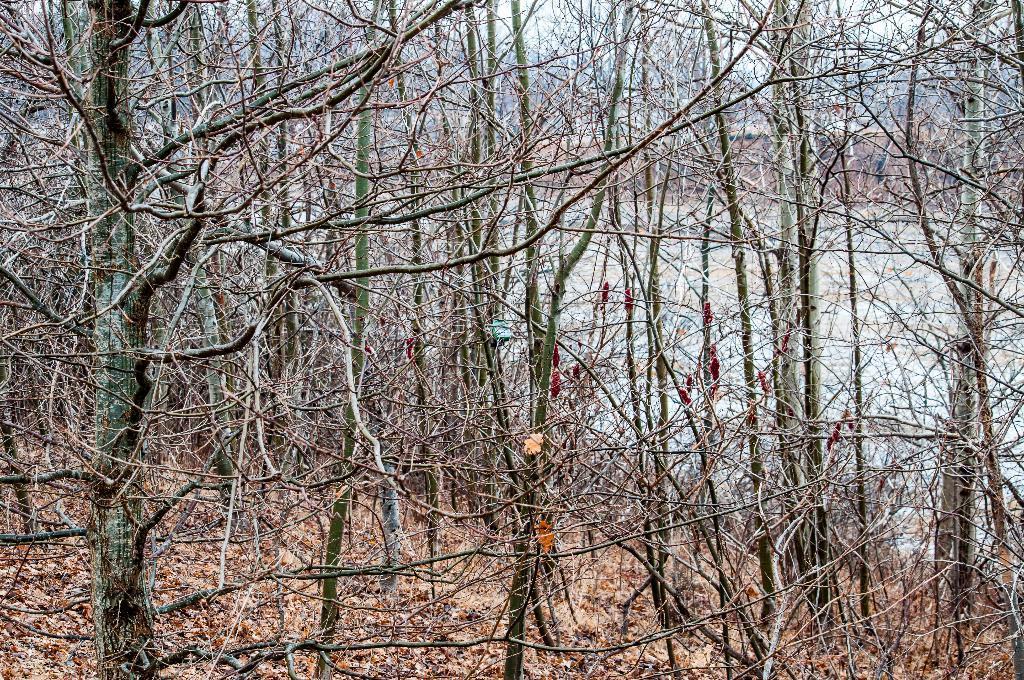Please provide a concise description of this image. In this picture, we see the trees. At the bottom, we see the dry leaves and twigs. There are trees in the background. 